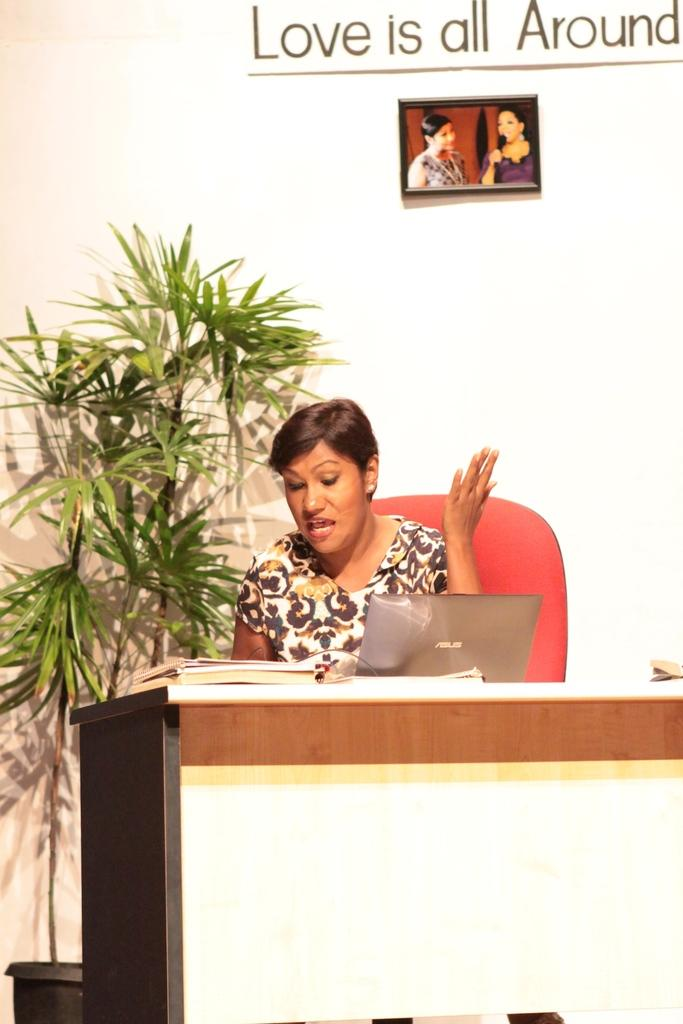Who is the main subject in the image? There is a lady in the center of the image. What is behind the lady in the image? The lady is in front of a desk. What items can be seen on the desk? There are books and a laptop on the desk. What can be seen in the background of the image? There are plants, a portrait, and text in the background. How does the lady's elbow look in the image? There is no mention of the lady's elbow in the provided facts, so we cannot answer this question. --- 